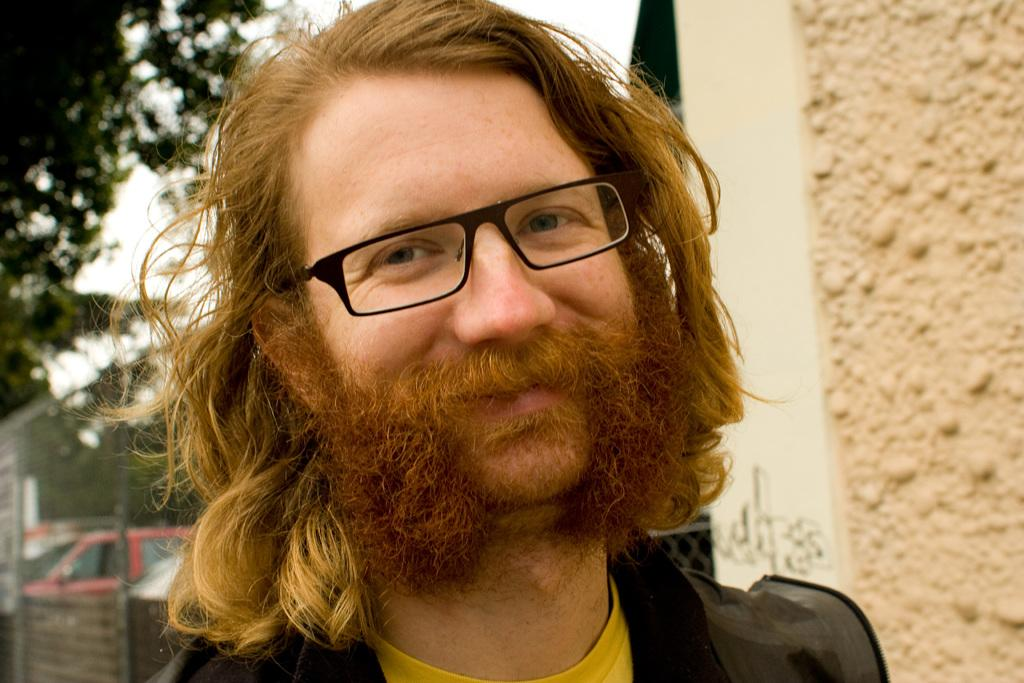Who or what is the main subject in the image? There is a person in the image. What can be observed about the person's appearance? The person is wearing specs. What is located on the right side of the image? There is a wall on the right side of the image. How would you describe the overall appearance of the image? The background appears blurry. What type of hair can be seen on the person in the image? There is no information about the person's hair in the provided facts, so we cannot determine the type of hair from the image. What is the texture of the glass in the image? There is no glass present in the image, so we cannot determine its texture. 